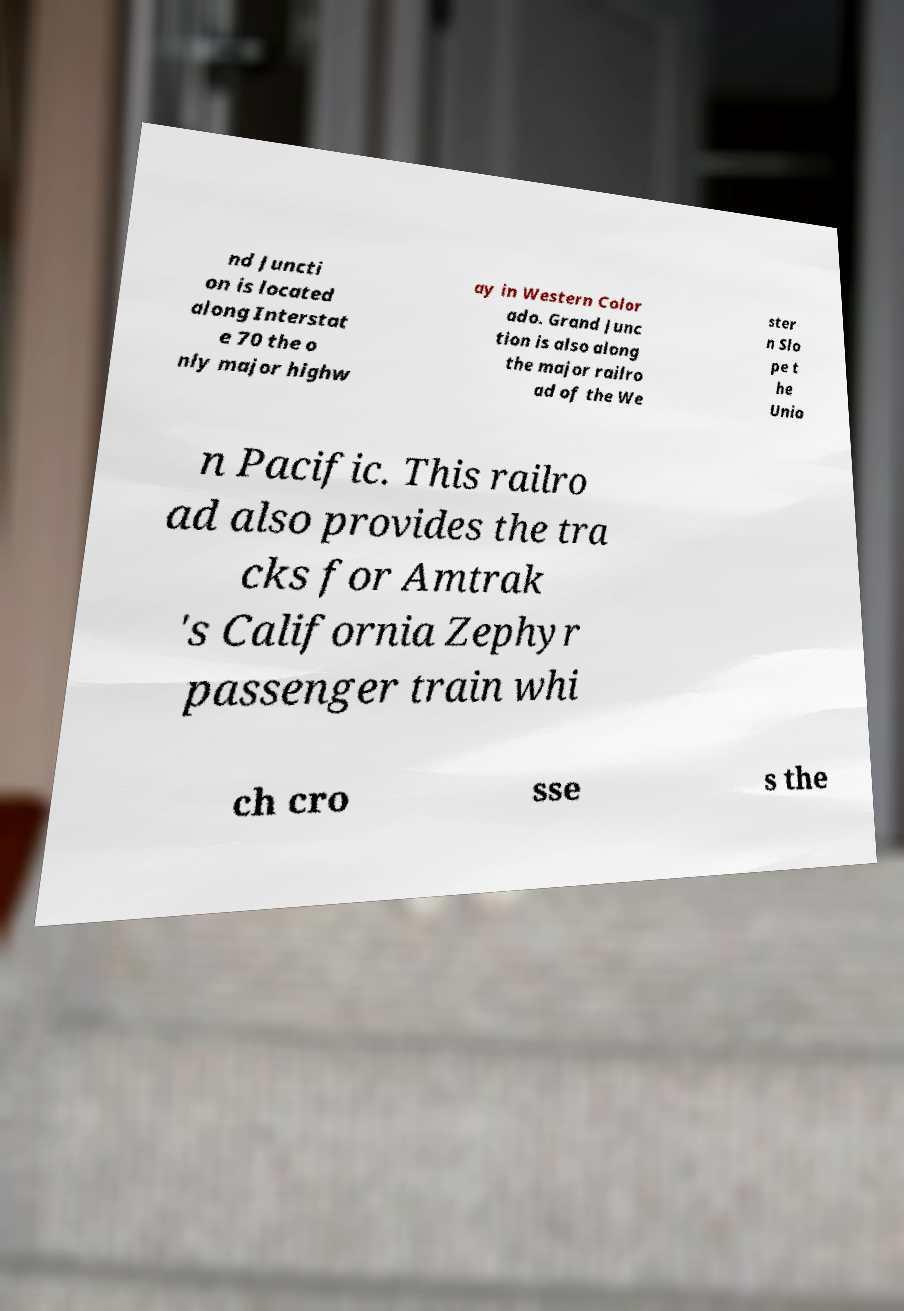I need the written content from this picture converted into text. Can you do that? nd Juncti on is located along Interstat e 70 the o nly major highw ay in Western Color ado. Grand Junc tion is also along the major railro ad of the We ster n Slo pe t he Unio n Pacific. This railro ad also provides the tra cks for Amtrak 's California Zephyr passenger train whi ch cro sse s the 